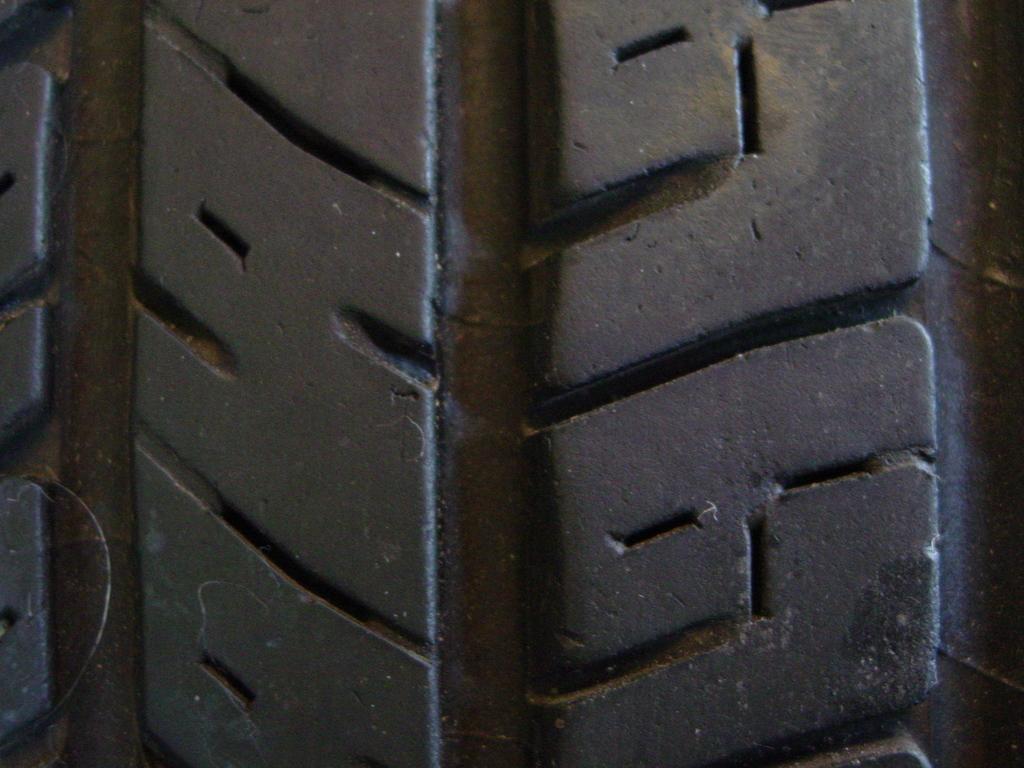Please provide a concise description of this image. In this image we can see a tire. 